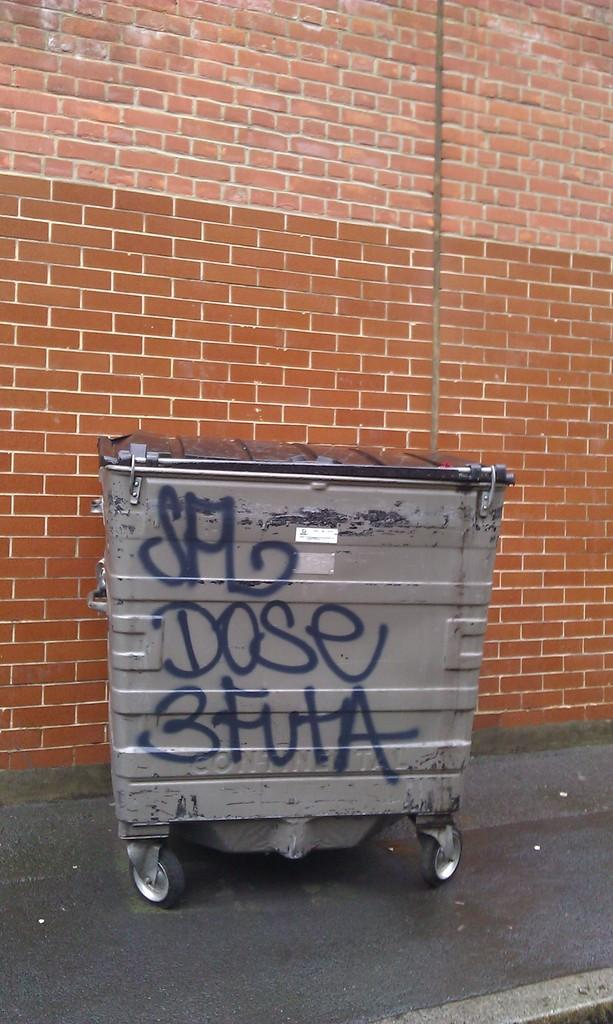<image>
Relay a brief, clear account of the picture shown. Grey colored trash bin outside with the word dose on it 